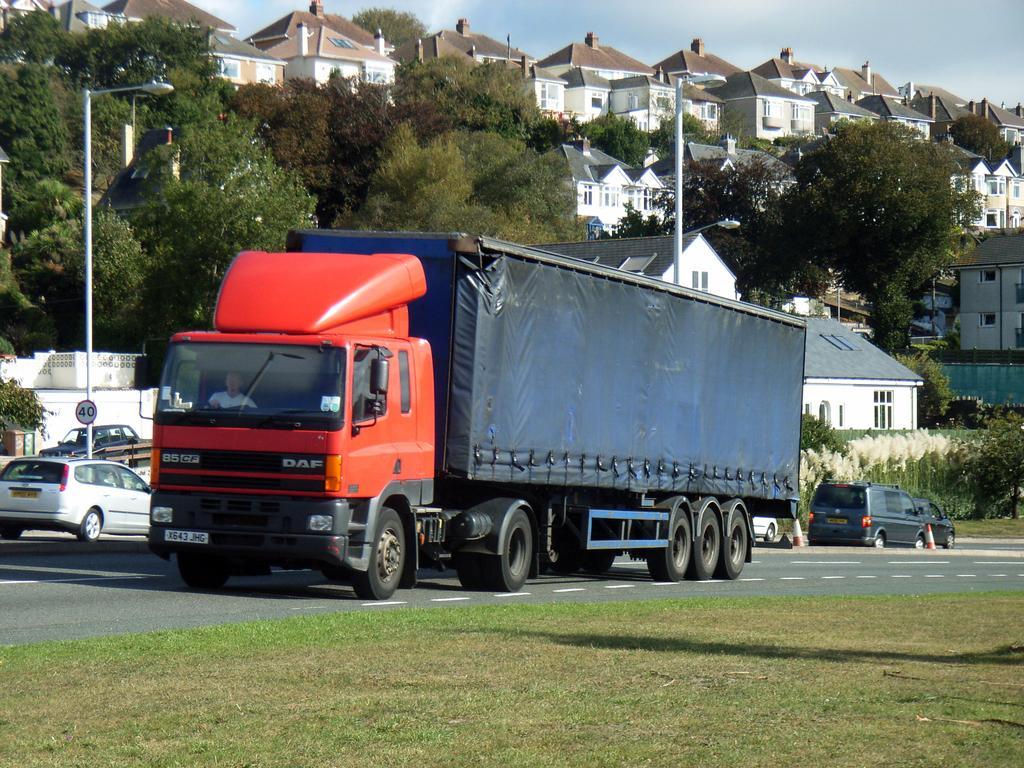Could you give a brief overview of what you see in this image? In this image I can see few roads in the centre and on it I can see number of vehicles. I can also see grass in the front and in the background. I can also see number of trees, number of buildings, few poles, few street lights, the sky and on the left side I can see a speed sign board. I can also see a person in the vehicle. 